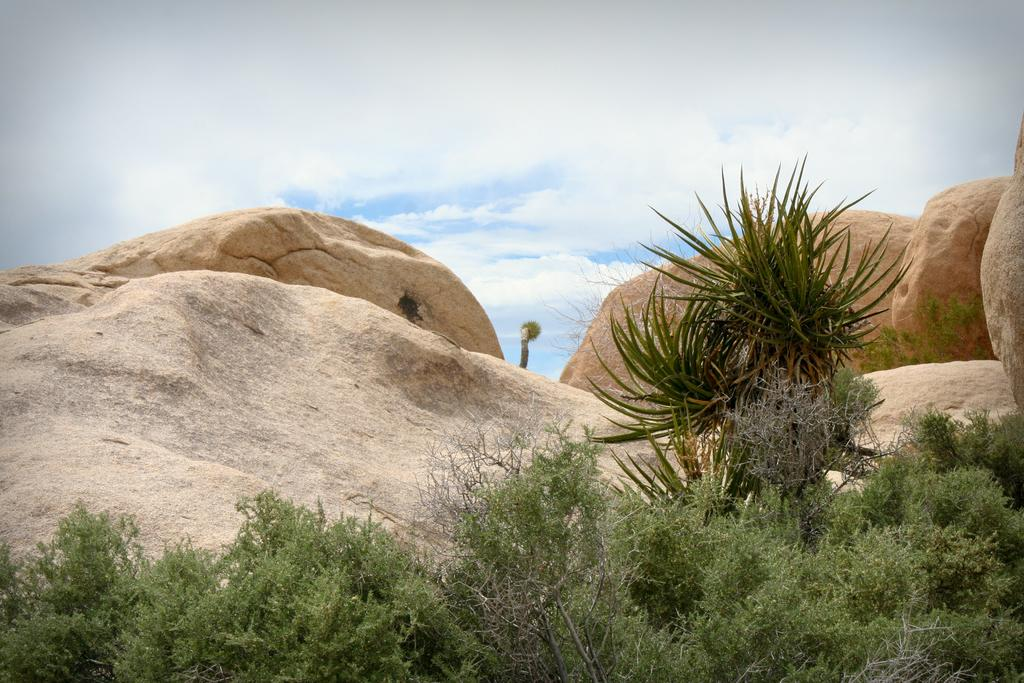What type of vegetation can be seen in the image? There is grass and plants in the image. What other natural elements are present in the image? There are rocks and a tree in the image. What is visible in the background of the image? The sky is visible in the image. What religious symbols can be seen in the image? There are no religious symbols present in the image. How does the thunder sound in the image? There is no thunder present in the image. 